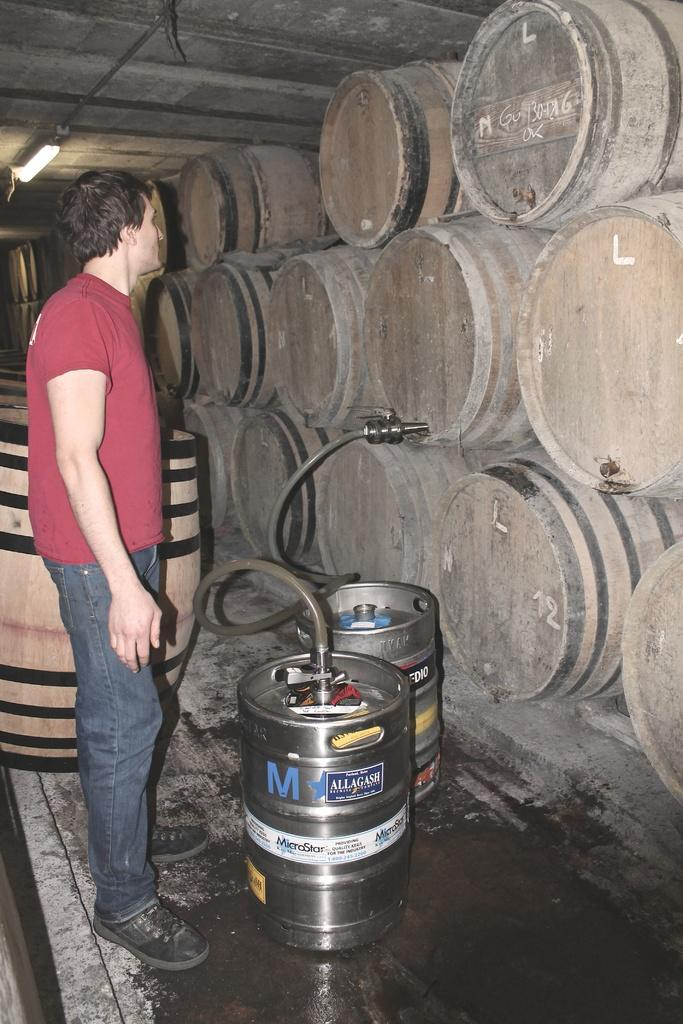What is the main subject of the image? There is a person in the image. What else can be seen in the image besides the person? There are containers visible in the image, and there is a pipe connection between two containers. What type of comb is the person using to teach the island in the image? There is no comb or island present in the image. The image features a person, containers, and a pipe connection between two containers. 